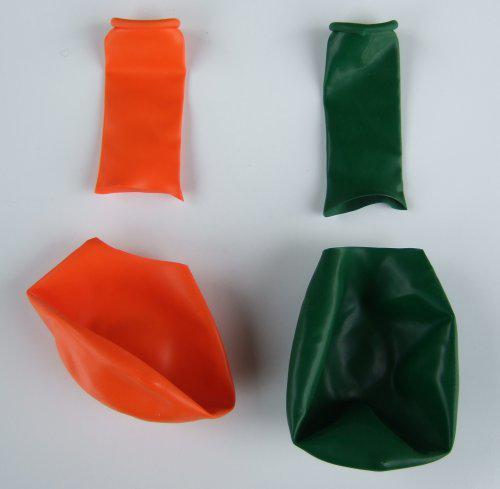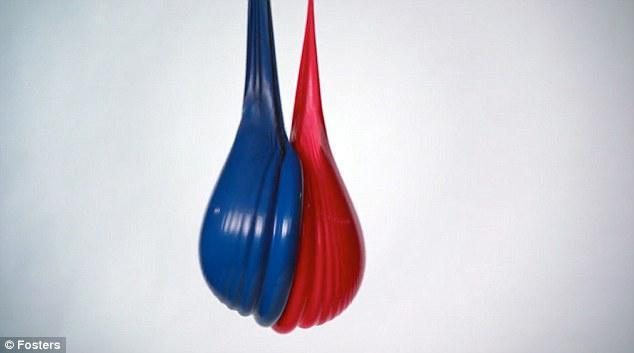The first image is the image on the left, the second image is the image on the right. Examine the images to the left and right. Is the description "Exactly one image shows liquid-like side-by-side drops of blue and red." accurate? Answer yes or no. Yes. 